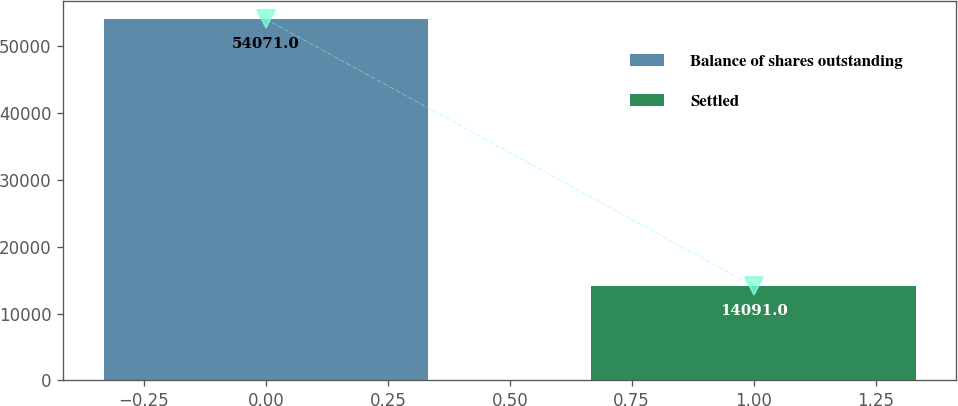Convert chart. <chart><loc_0><loc_0><loc_500><loc_500><bar_chart><fcel>Balance of shares outstanding<fcel>Settled<nl><fcel>54071<fcel>14091<nl></chart> 